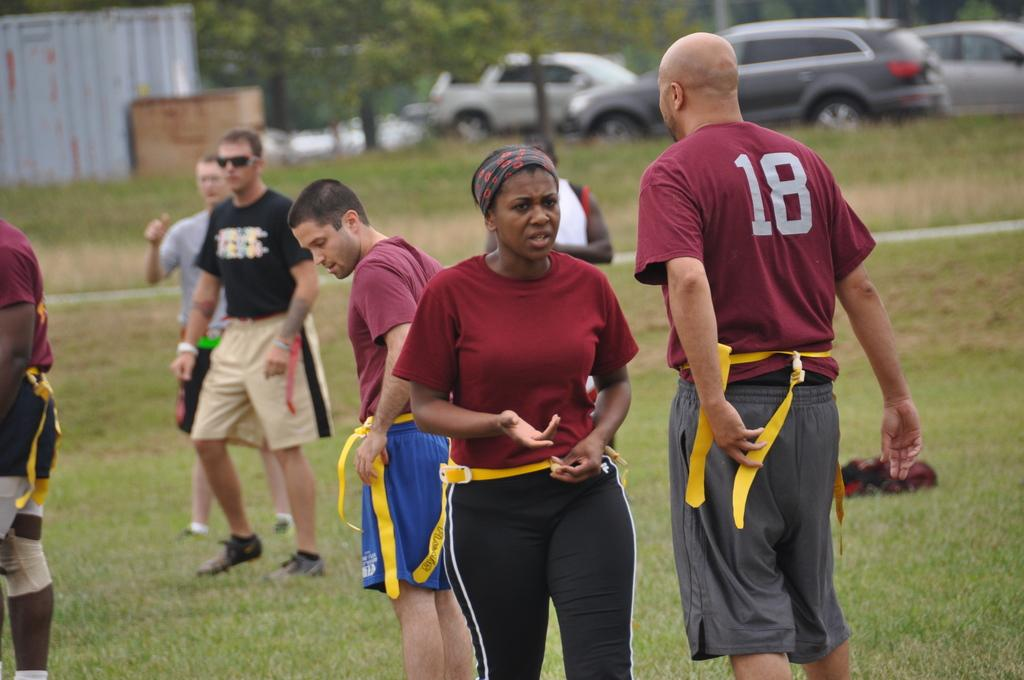How many people are in the image? There is a group of people in the image, but the exact number is not specified. What are the people in the image doing? The people are on the ground, but their specific activity is not mentioned. What can be seen in the background of the image? There are vehicles and trees in the background of the image. What type of chain is being used to start the alarm in the image? There is no chain or alarm present in the image. 